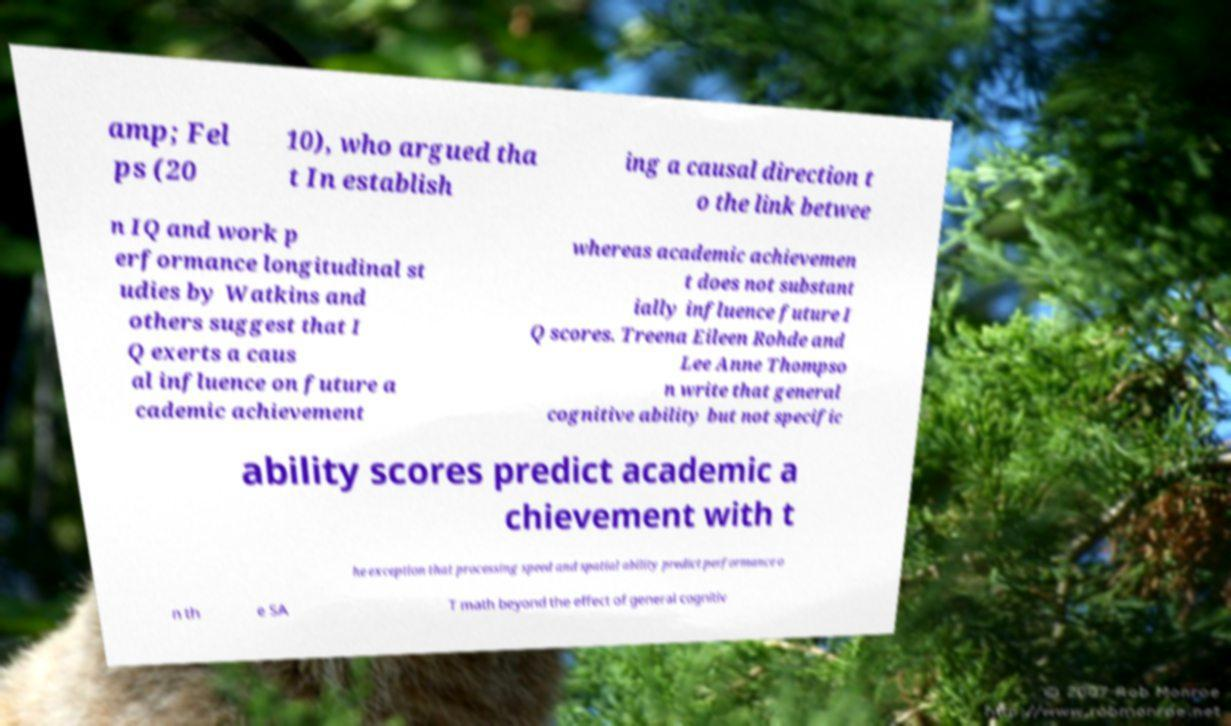For documentation purposes, I need the text within this image transcribed. Could you provide that? amp; Fel ps (20 10), who argued tha t In establish ing a causal direction t o the link betwee n IQ and work p erformance longitudinal st udies by Watkins and others suggest that I Q exerts a caus al influence on future a cademic achievement whereas academic achievemen t does not substant ially influence future I Q scores. Treena Eileen Rohde and Lee Anne Thompso n write that general cognitive ability but not specific ability scores predict academic a chievement with t he exception that processing speed and spatial ability predict performance o n th e SA T math beyond the effect of general cognitiv 